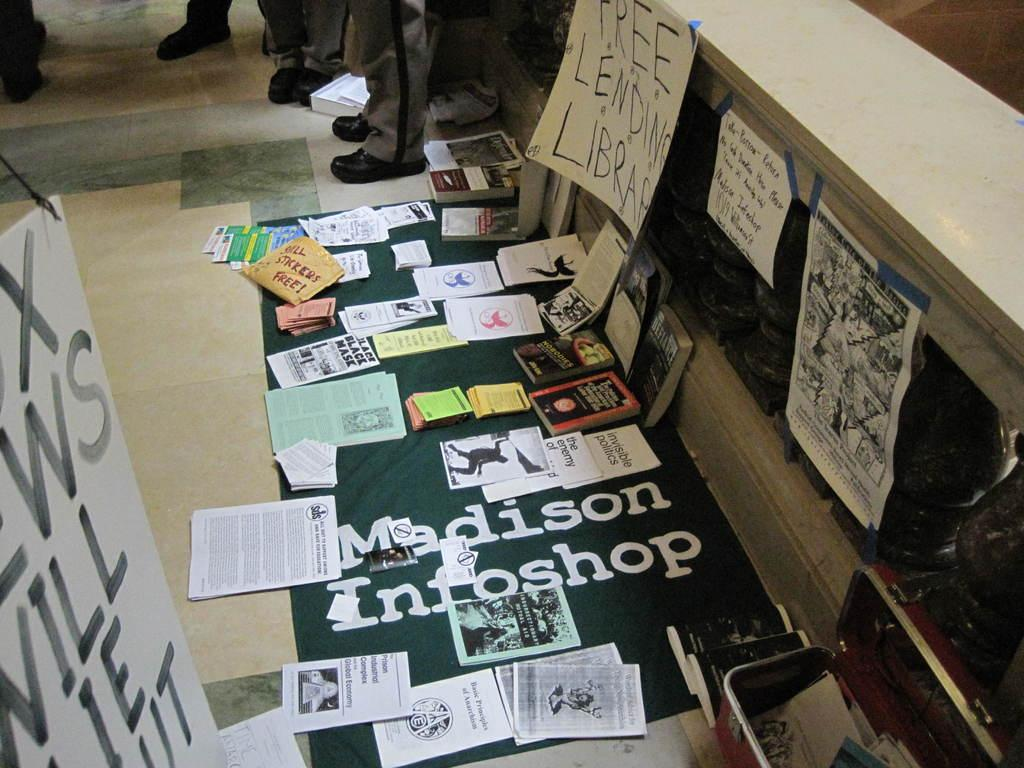What type of objects can be seen in the image? Papers, books, and posters are visible in the image. Can you describe the contents of the image in more detail? Yes, there are papers, books, and posters present in the image. What might be the purpose of the objects in the image? The papers, books, and posters could be used for reading, studying, or decoration. Are there any people visible in the image? In the background, there are legs of persons visible. How many frogs are sitting on the books in the image? There are no frogs present in the image; it only contains papers, books, and posters. What type of rail can be seen in the image? There is no rail present in the image. 